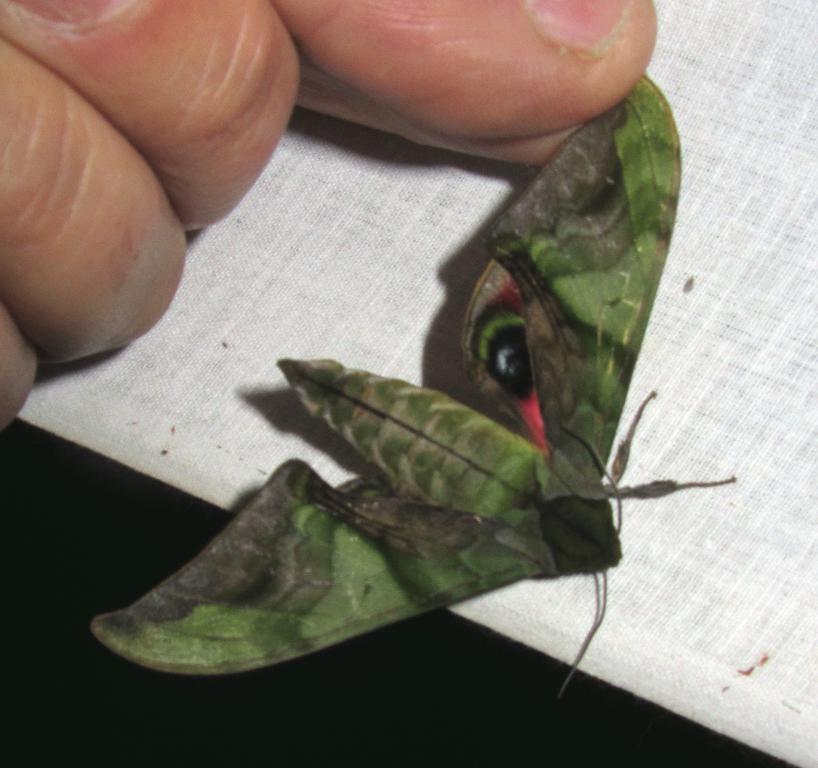Describe this image in one or two sentences. In this picture there is a person holding the green color butterfly and at the bottom there is a white color cloth. 